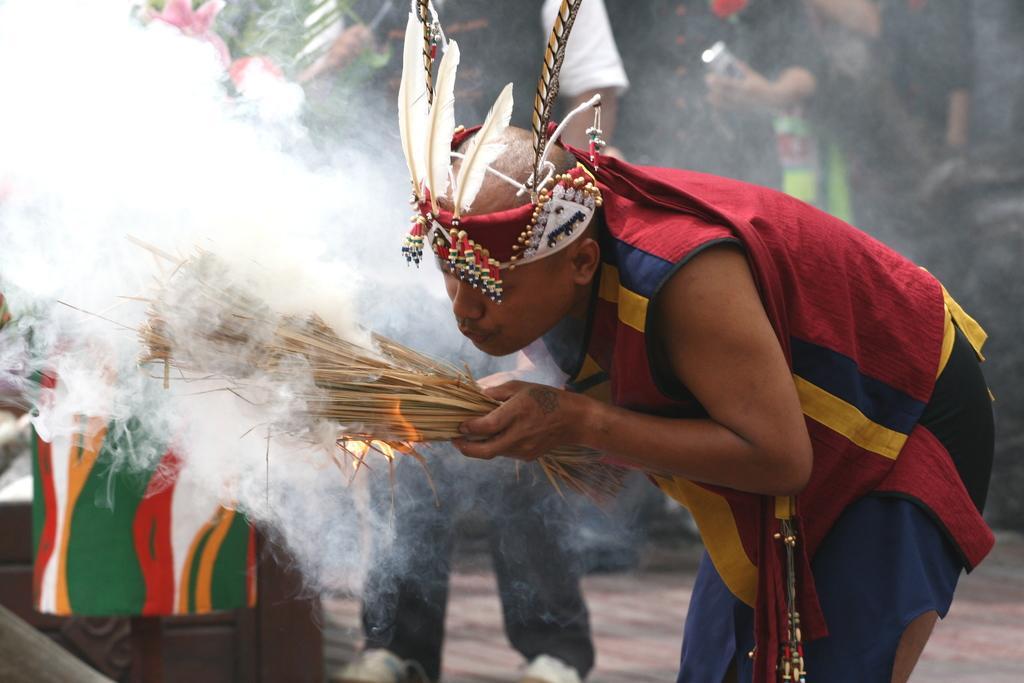In one or two sentences, can you explain what this image depicts? In this image we can see a person wearing red color costume and crown which has feathers blowing some air to the sticks which got fire and in the background of the image there are some persons standing. 